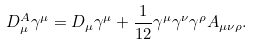<formula> <loc_0><loc_0><loc_500><loc_500>D ^ { A } _ { \mu } \gamma ^ { \mu } = D _ { \mu } \gamma ^ { \mu } + \frac { 1 } { 1 2 } \gamma ^ { \mu } \gamma ^ { \nu } \gamma ^ { \rho } A _ { \mu \nu \rho } .</formula> 